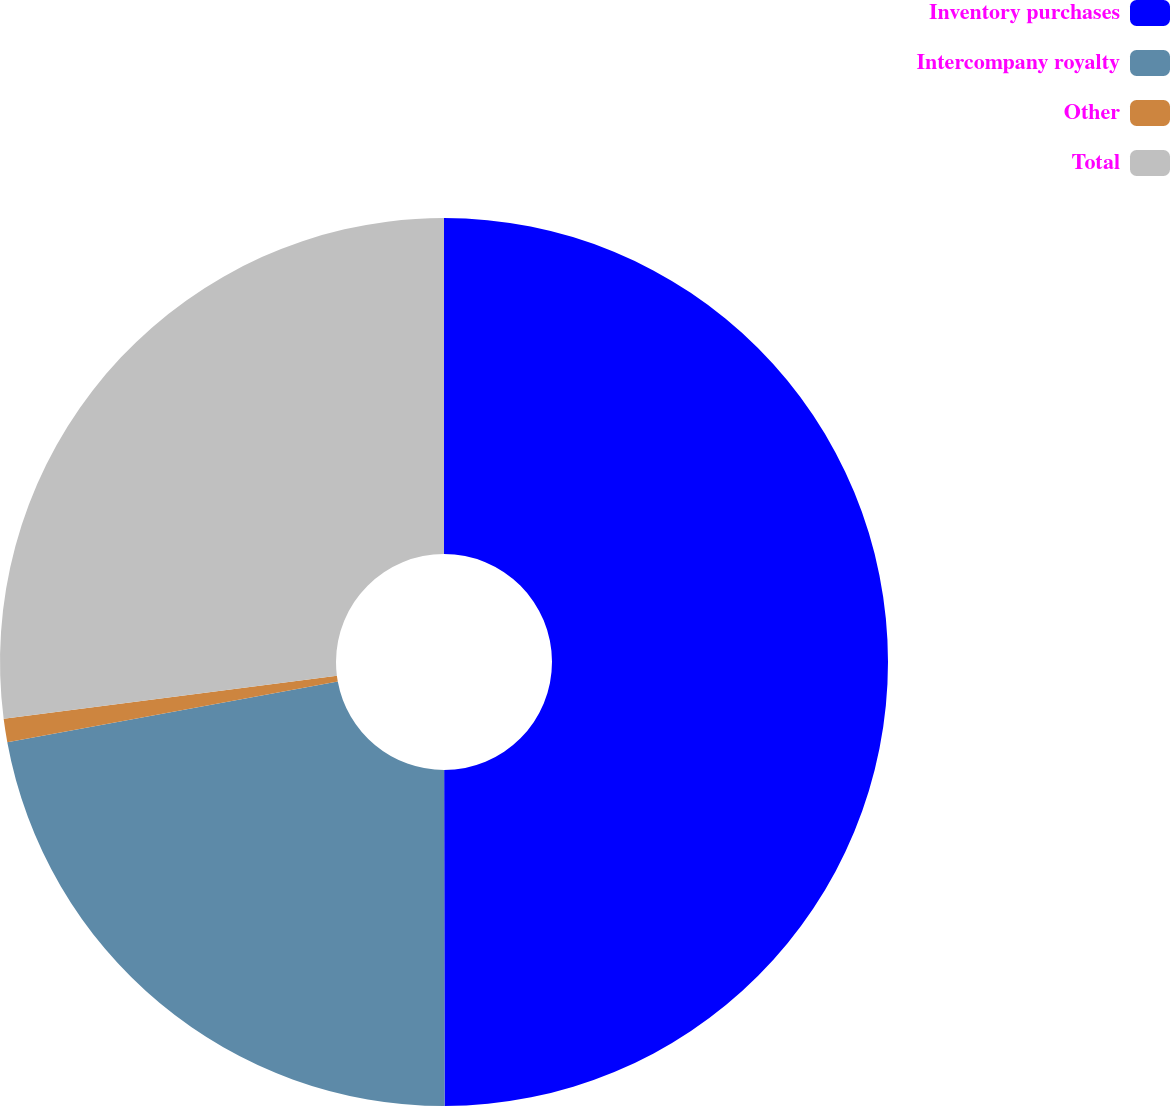<chart> <loc_0><loc_0><loc_500><loc_500><pie_chart><fcel>Inventory purchases<fcel>Intercompany royalty<fcel>Other<fcel>Total<nl><fcel>49.98%<fcel>22.13%<fcel>0.85%<fcel>27.04%<nl></chart> 